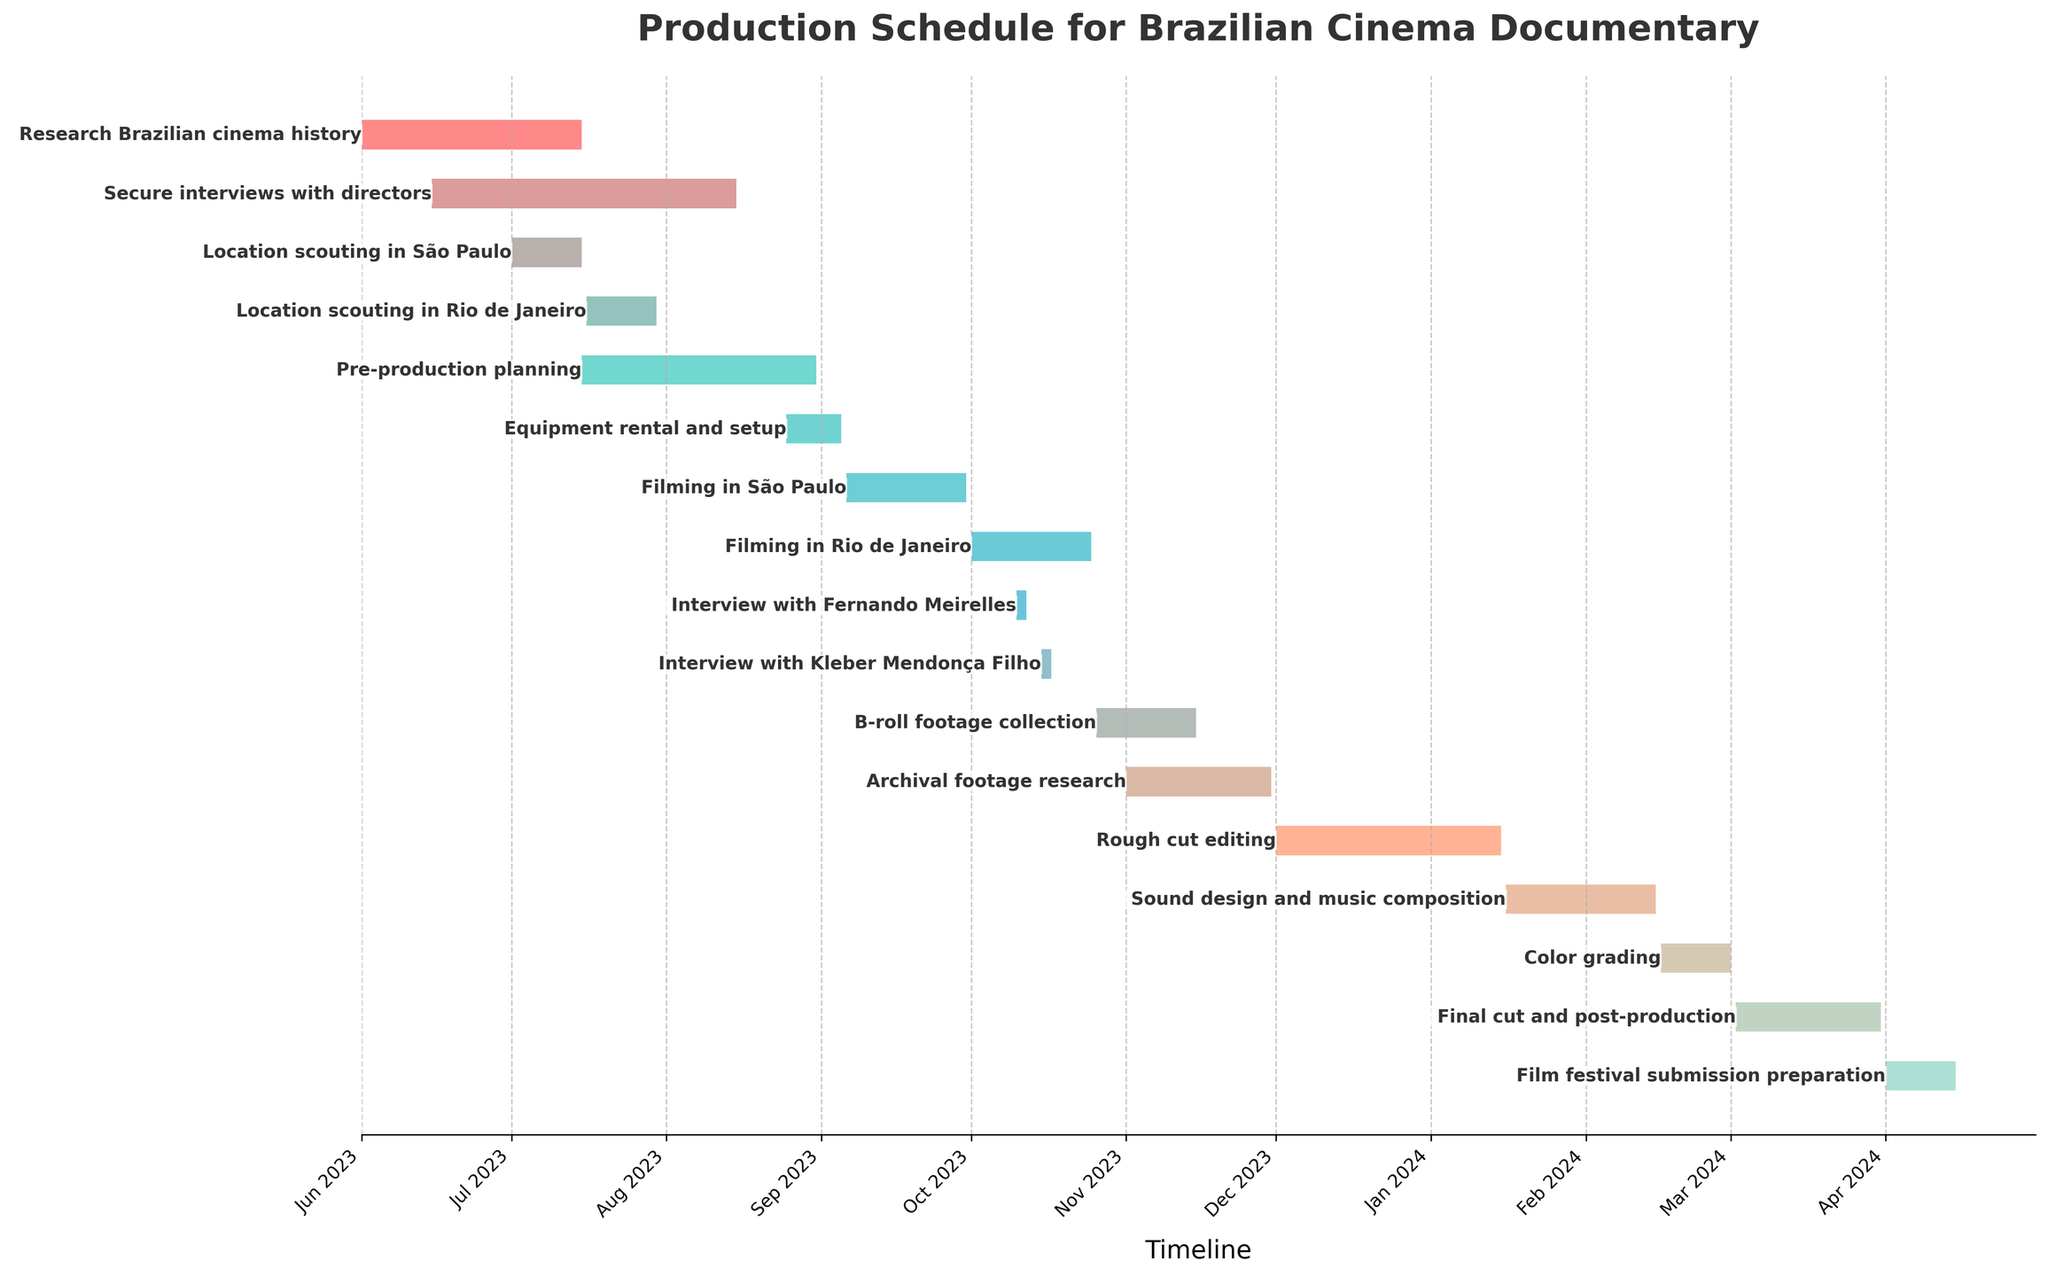How many tasks are included in the production schedule? By counting the number of bars in the Gantt chart, we can determine the total number of tasks included.
Answer: 16 What is the title of the Gantt chart? The title of the plot is usually displayed at the top center of the chart.
Answer: Production Schedule for Brazilian Cinema Documentary Which task has the longest duration, and how many days does it span? By looking at the length of the bars, the longest bar represents the task with the longest duration. We can check the task name and count the days from start to end.
Answer: Research Brazilian cinema history, 45 days Which task starts the latest in the schedule? The task that starts the latest is the one farthest to the right in the Gantt chart, where we look at the start date.
Answer: Film festival submission preparation During which months does the majority of the "Filming in São Paulo" task occur? By locating the "Filming in São Paulo" bar and referring to the dates on the x-axis to determine the months involved.
Answer: September How many tasks begin in July 2023? By looking at the bars that start in July and counting each occurrence, we determine the tasks that begin in that month.
Answer: 3 Which tasks overlap with "Filming in Rio de Janeiro"? We identify the bar for "Filming in Rio de Janeiro" and check which other bars overlap in duration with this bar.
Answer: Interview with Fernando Meirelles, Interview with Kleber Mendonça Filho What's the duration of the "Rough cut editing" task and in which months does it occur? By checking the start and end dates of the "Rough cut editing" bar, we can calculate the duration and identify the months it spans.
Answer: 45 days, December to January Which task starts immediately after "Pre-production planning"? By checking the end date of "Pre-production planning" and looking at the next task that starts after this date.
Answer: Equipment rental and setup How many tasks are scheduled to occur in 2024? By identifying the tasks that have bars in the 2024 section of the Gantt chart and counting them.
Answer: 5 